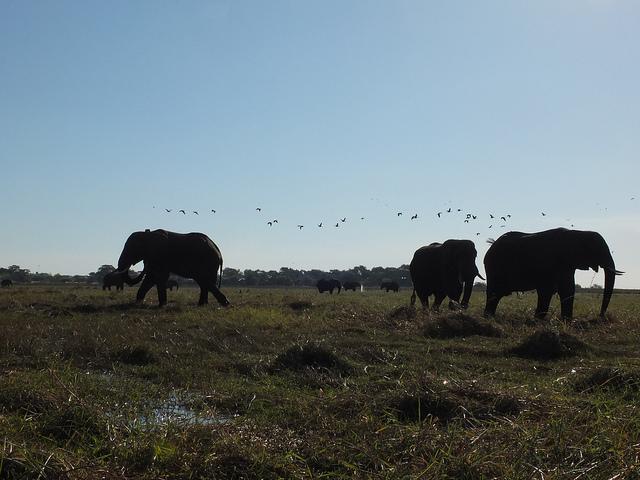How many bulls are in the picture?
Quick response, please. 0. Is this foto clear?
Be succinct. Yes. What different types of animals are in the picture?
Be succinct. Elephants and birds. How many animals can be seen?
Be succinct. 7. What are these animals doing?
Short answer required. Walking. Are there more than one type of animal?
Keep it brief. Yes. Is the sun near the horizon in the image?
Give a very brief answer. No. How many animals are in this photo?
Write a very short answer. 3. Is the sky blue?
Short answer required. Yes. What is eating the grass?
Concise answer only. Elephants. 